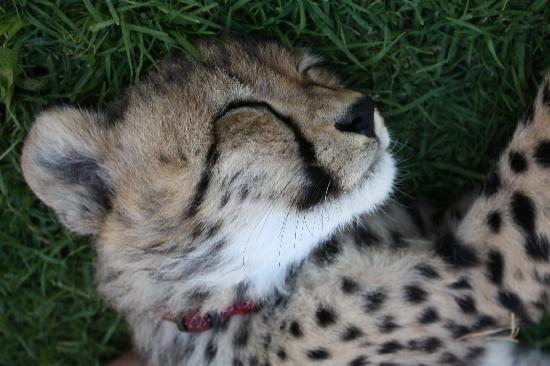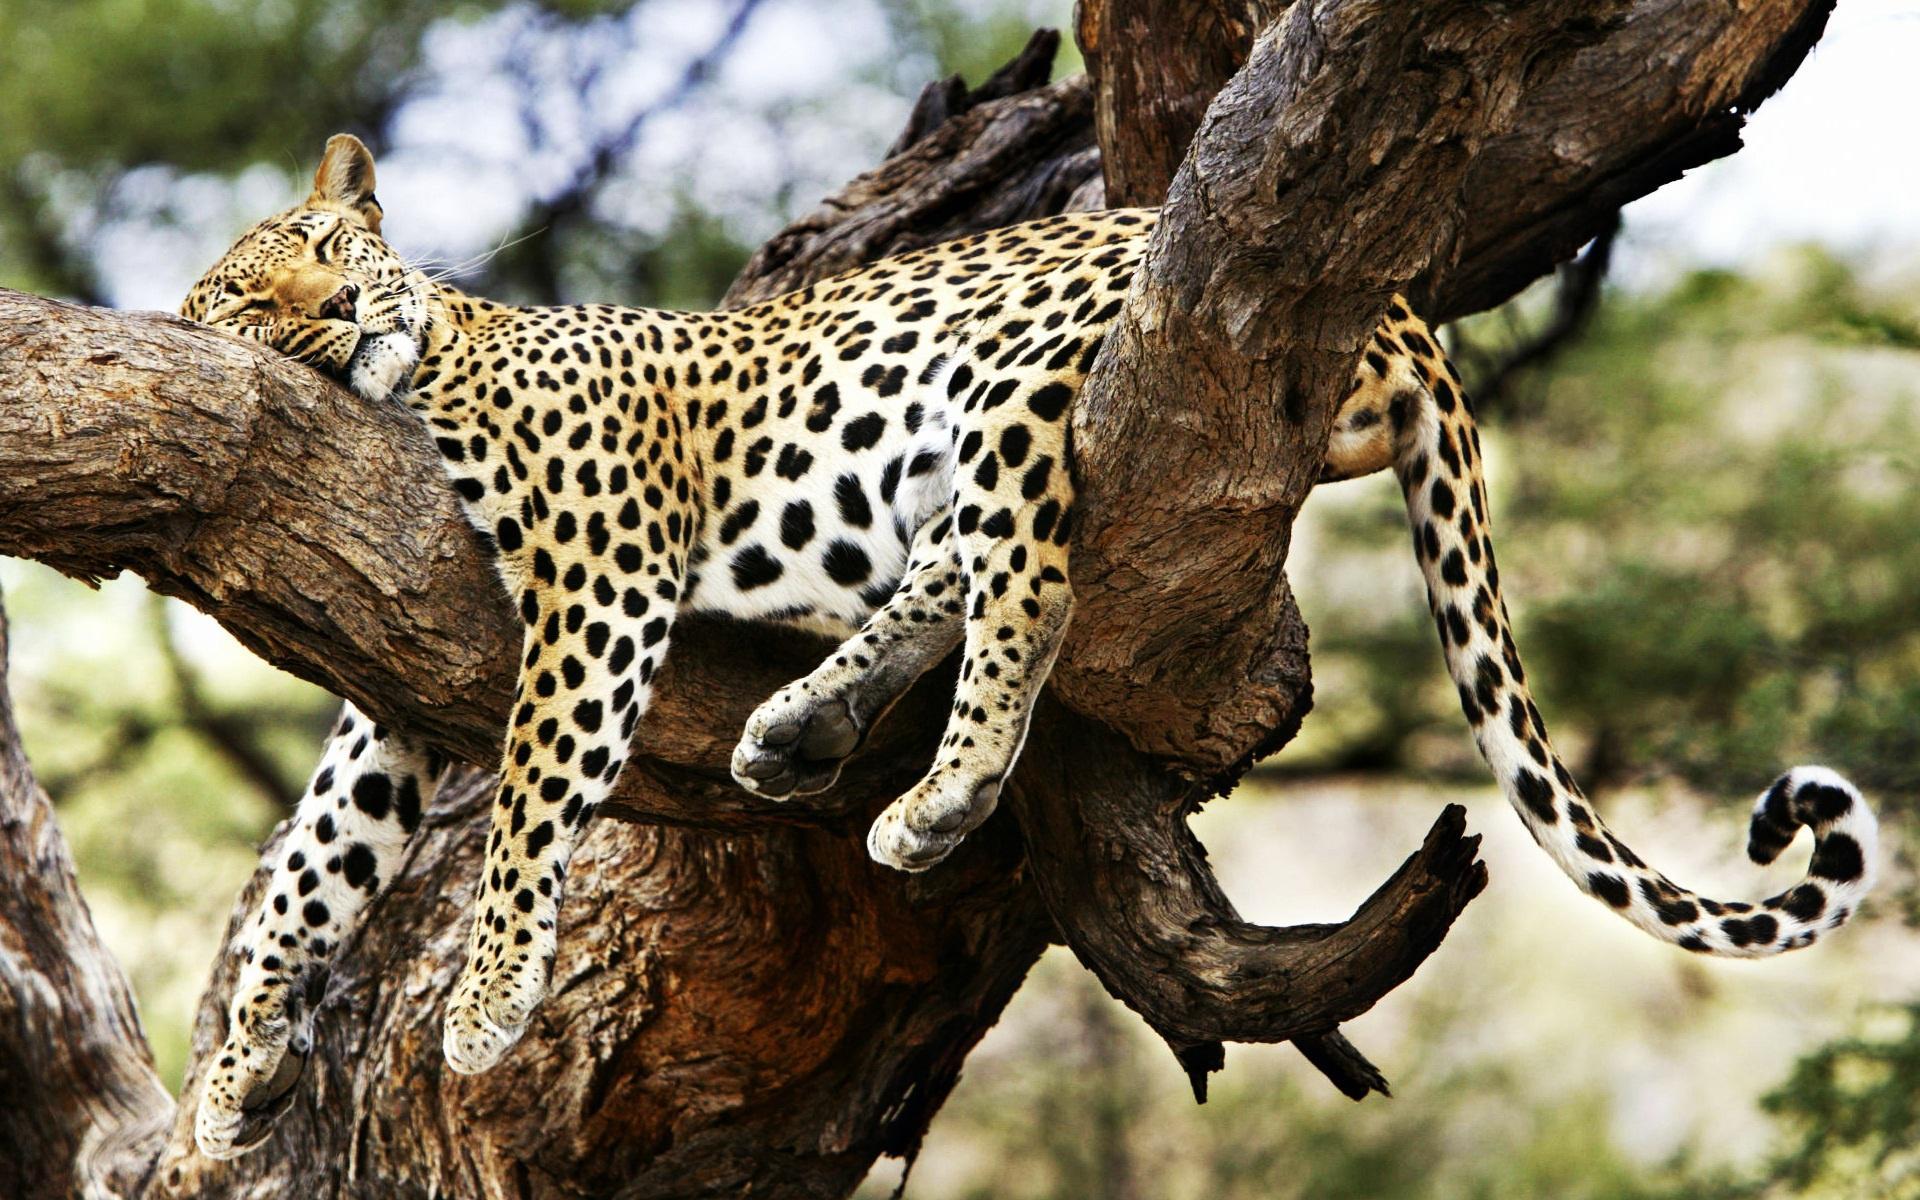The first image is the image on the left, the second image is the image on the right. Examine the images to the left and right. Is the description "There is a cheetah sleeping in a tree" accurate? Answer yes or no. Yes. The first image is the image on the left, the second image is the image on the right. For the images shown, is this caption "There is one cheetah sleeping in a tree." true? Answer yes or no. Yes. 